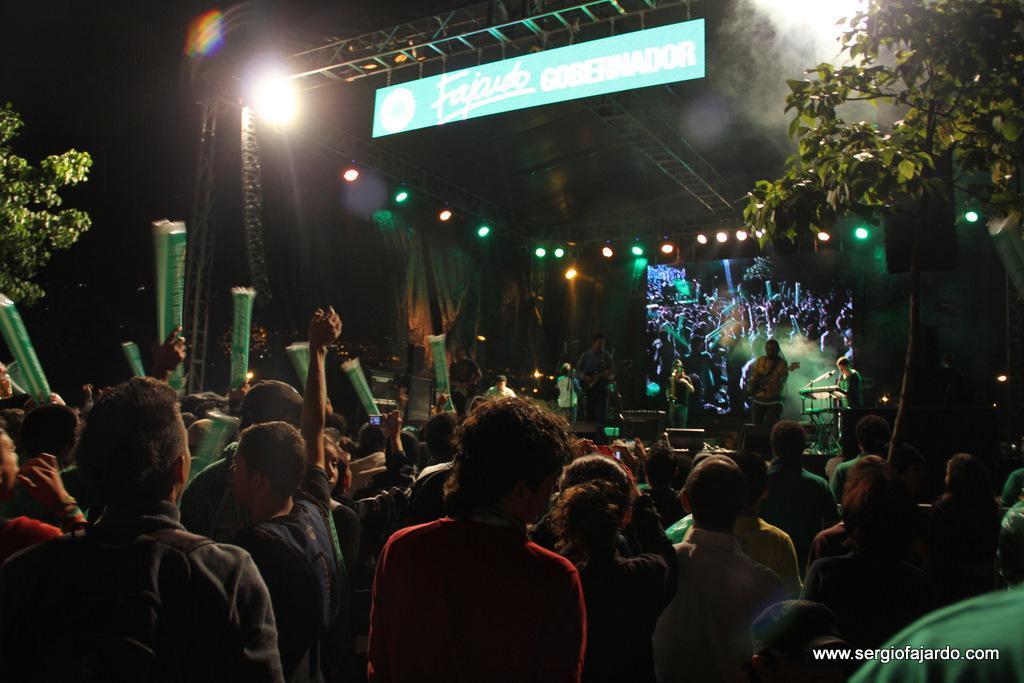Describe this image in one or two sentences. This image is taken in the dark. This is like a music concert and I can see a person standing and holding a guitar and a group of audience holding some objects in their hands and some lights.  